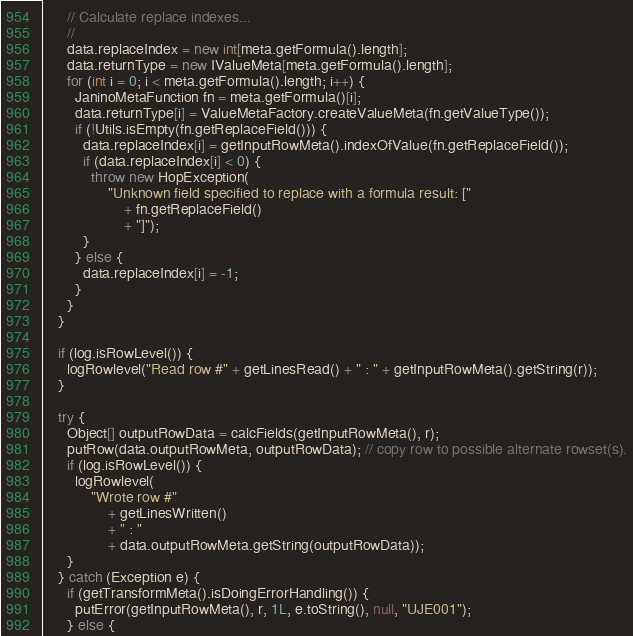Convert code to text. <code><loc_0><loc_0><loc_500><loc_500><_Java_>
      // Calculate replace indexes...
      //
      data.replaceIndex = new int[meta.getFormula().length];
      data.returnType = new IValueMeta[meta.getFormula().length];
      for (int i = 0; i < meta.getFormula().length; i++) {
        JaninoMetaFunction fn = meta.getFormula()[i];
        data.returnType[i] = ValueMetaFactory.createValueMeta(fn.getValueType());
        if (!Utils.isEmpty(fn.getReplaceField())) {
          data.replaceIndex[i] = getInputRowMeta().indexOfValue(fn.getReplaceField());
          if (data.replaceIndex[i] < 0) {
            throw new HopException(
                "Unknown field specified to replace with a formula result: ["
                    + fn.getReplaceField()
                    + "]");
          }
        } else {
          data.replaceIndex[i] = -1;
        }
      }
    }

    if (log.isRowLevel()) {
      logRowlevel("Read row #" + getLinesRead() + " : " + getInputRowMeta().getString(r));
    }

    try {
      Object[] outputRowData = calcFields(getInputRowMeta(), r);
      putRow(data.outputRowMeta, outputRowData); // copy row to possible alternate rowset(s).
      if (log.isRowLevel()) {
        logRowlevel(
            "Wrote row #"
                + getLinesWritten()
                + " : "
                + data.outputRowMeta.getString(outputRowData));
      }
    } catch (Exception e) {
      if (getTransformMeta().isDoingErrorHandling()) {
        putError(getInputRowMeta(), r, 1L, e.toString(), null, "UJE001");
      } else {</code> 